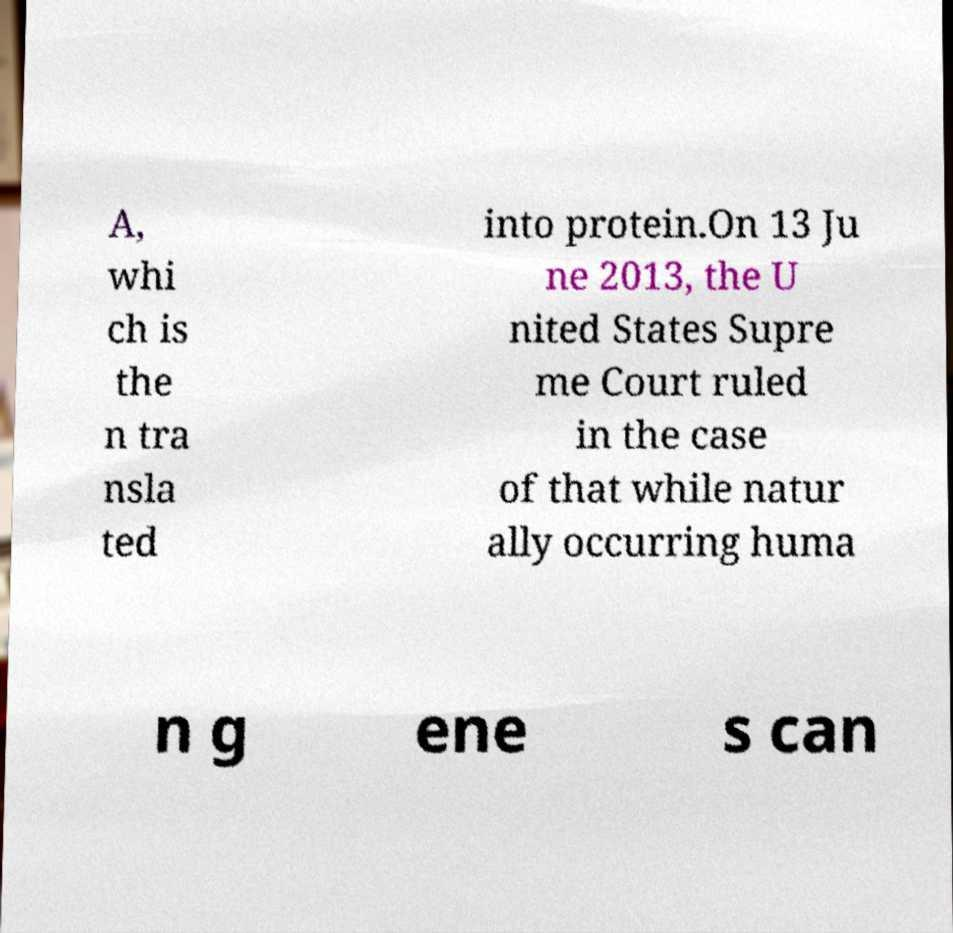There's text embedded in this image that I need extracted. Can you transcribe it verbatim? A, whi ch is the n tra nsla ted into protein.On 13 Ju ne 2013, the U nited States Supre me Court ruled in the case of that while natur ally occurring huma n g ene s can 